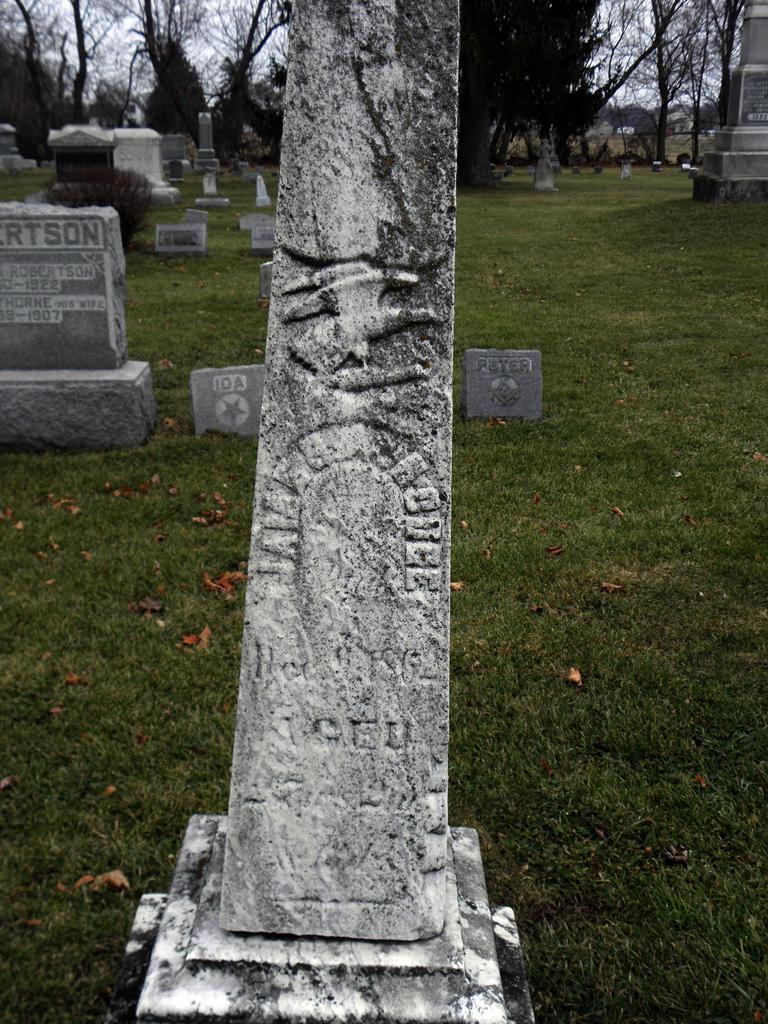Describe this image in one or two sentences. In this image in the front there is a pillar. In the center there are stones with some text written on it and there is grass on the ground and there are dry leaves on the ground. In the background there are trees and stones. 